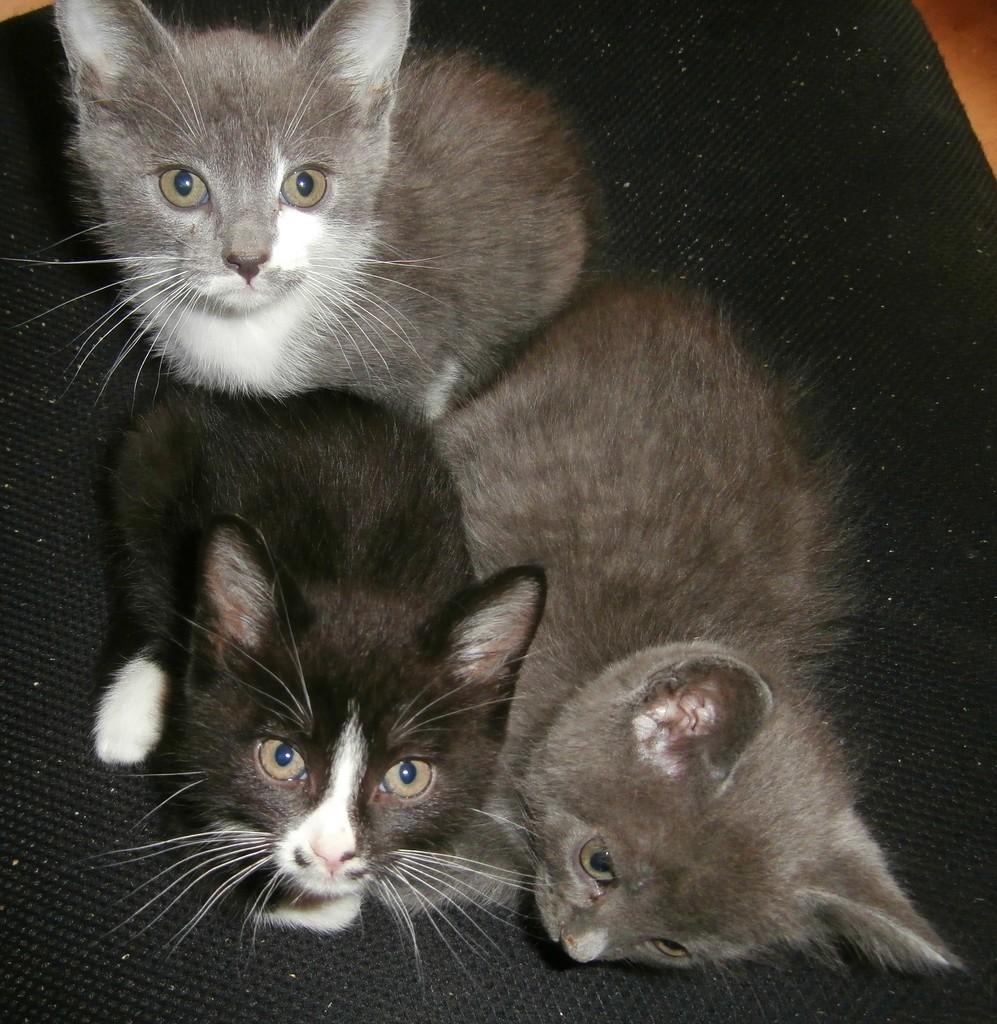Can you describe this image briefly? In this picture, there are three cats which are in black and grey in color. At the bottom, there is a mat. 